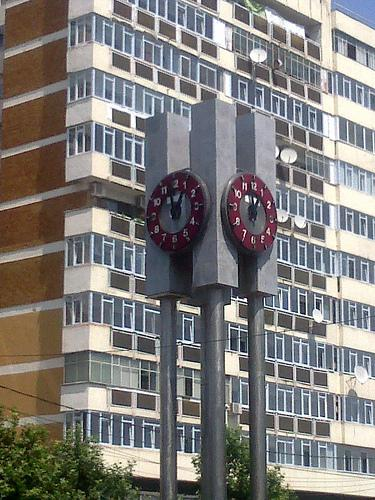Question: what is in front of the building?
Choices:
A. Timepieces.
B. Chronometers.
C. Clocks.
D. Clock tower.
Answer with the letter. Answer: C Question: how many clocks?
Choices:
A. 3.
B. 2.
C. 4.
D. 5.
Answer with the letter. Answer: B Question: what is behind the clocks?
Choices:
A. Building.
B. A large structure.
C. A house.
D. A business.
Answer with the letter. Answer: A Question: who will see the clocks?
Choices:
A. Tourists.
B. Students.
C. People.
D. The crowd.
Answer with the letter. Answer: C Question: what are the clocks on?
Choices:
A. Supports.
B. Poles.
C. Stakes.
D. Bars.
Answer with the letter. Answer: B Question: when is it?
Choices:
A. After lunch.
B. Afternoon.
C. 12:59 pm.
D. Midday.
Answer with the letter. Answer: C 